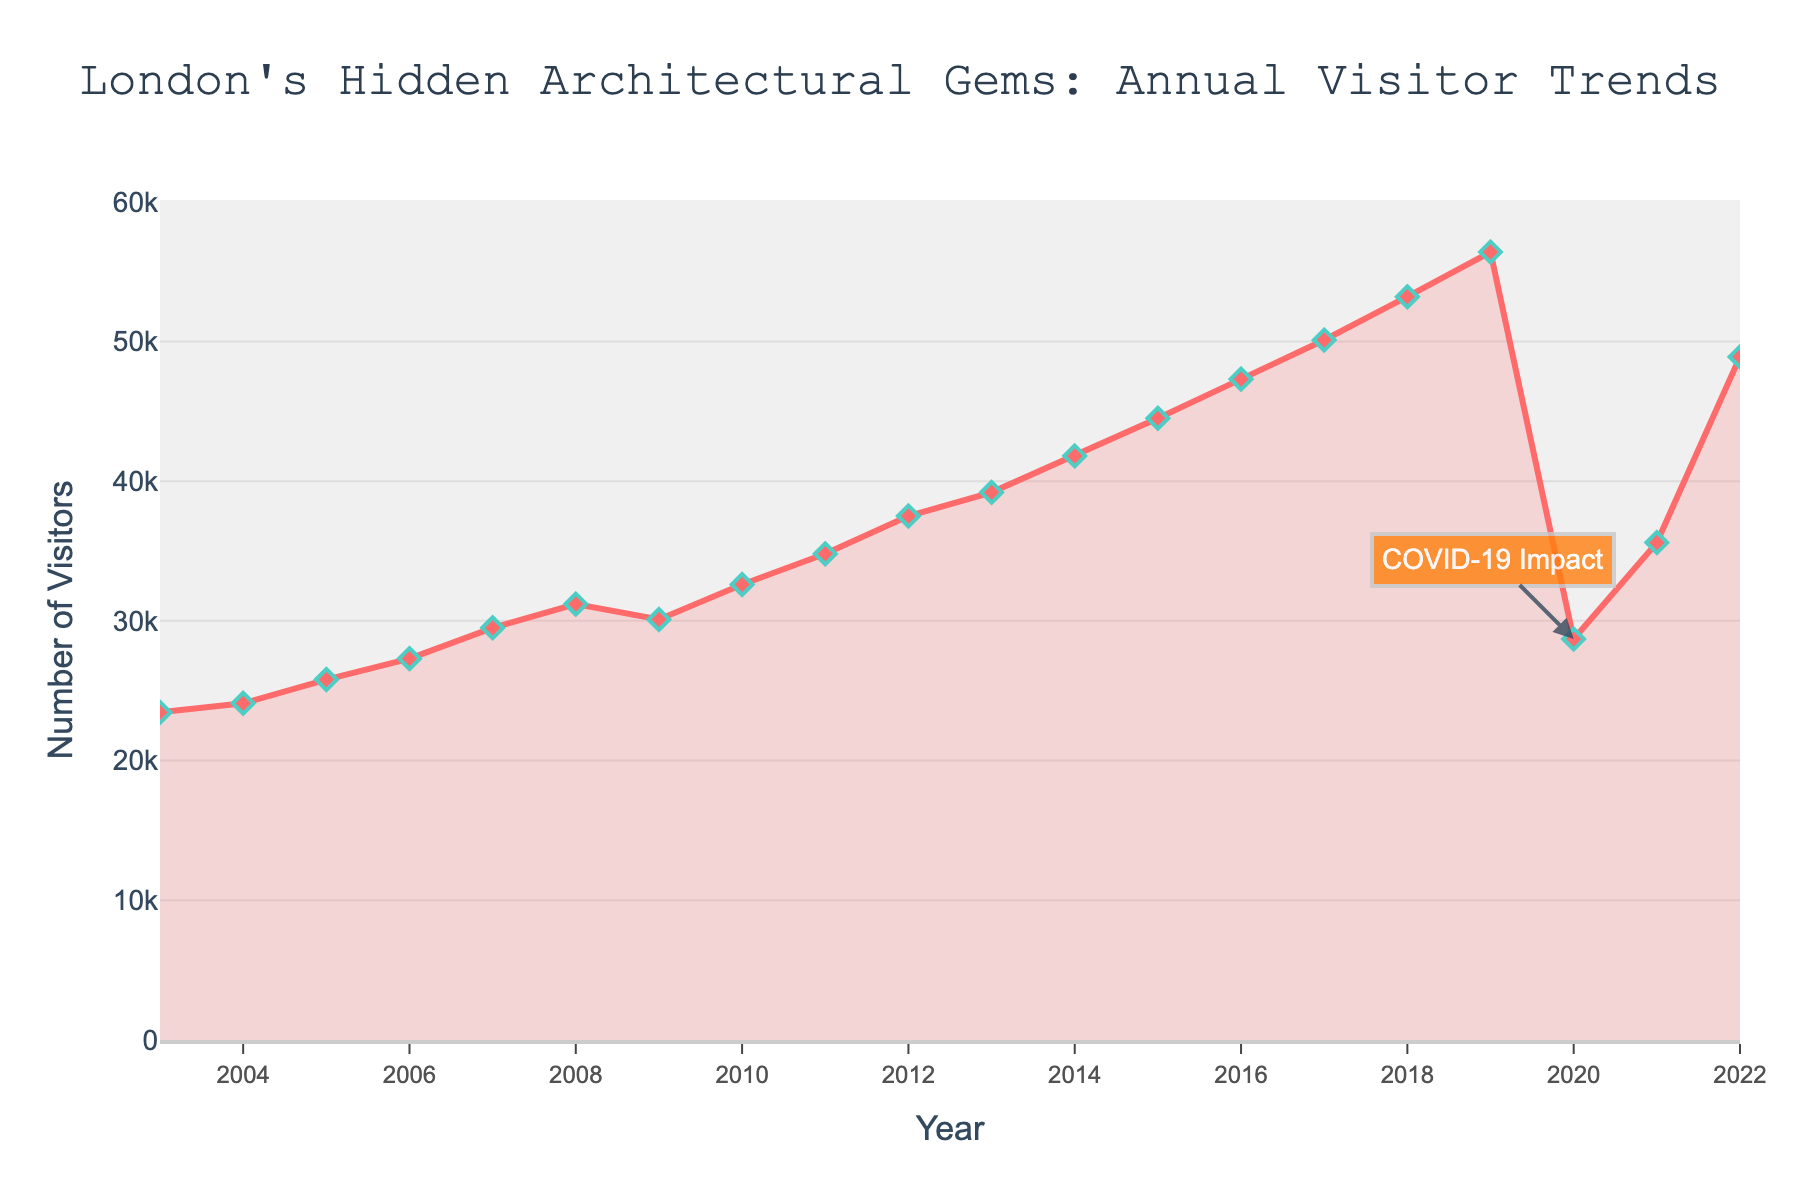What's the trend of visitor numbers over the past 20 years? The visitor numbers generally show an upward trend, with a noticeable dip in 2020 and a sharp increase again in 2021 and 2022.
Answer: Upward trend Which year had the lowest visitor numbers after 2010, and what might be the cause of this decline? 2020 had the lowest visitor numbers after 2010, which can be attributed to the impact of COVID-19 as indicated by the annotation on the figure.
Answer: 2020, COVID-19 Impact In which year(s) did visitor numbers surpass 50,000? Visitor numbers surpassed 50,000 in the years 2017, 2018, 2019, and 2022.
Answer: 2017, 2018, 2019, 2022 How do the visitor numbers in 2022 compare to those in 2019? Visitor numbers in 2022 were lower than those in 2019, with 48,900 visitors in 2022 compared to 56,400 visitors in 2019.
Answer: 2022 lower than 2019 By how much did the visitor numbers increase from 2003 to 2019? Visitor numbers increased from 23,450 in 2003 to 56,400 in 2019. The increase can be calculated as 56,400 - 23,450 = 32,950.
Answer: Increase by 32,950 What is the steepest year-to-year increase in visitor numbers, and what are the years involved? The steepest year-to-year increase is between 2021 and 2022, with an increase from 35,600 to 48,900, which is an increase of 13,300 visitors.
Answer: Between 2021 and 2022 What's the average number of visitors from 2010 to 2015? The visitor numbers from 2010 to 2015 are 32,600, 34,800, 37,500, 39,200, 41,800, and 44,500. Sum them up to get 230,400 and divide by 6. The average is 230,400 / 6 = 38,400.
Answer: 38,400 Which year represents a recovery phase after the 2020 dip, and how much did visitor numbers increase that year? The year 2021 represents a recovery phase after the 2020 dip, with visitor numbers increasing from 28,700 in 2020 to 35,600 in 2021. The increase is 35,600 - 28,700 = 6,900.
Answer: 2021, increase by 6,900 